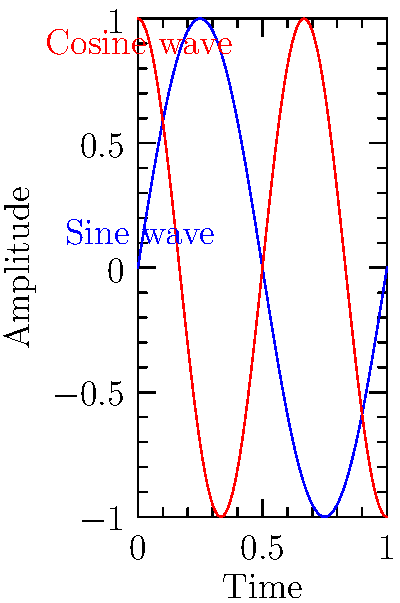In analyzing the rhythmic patterns of an eco-poem, you've mapped two recurring motifs to trigonometric functions. The blue curve represents the frequency of nature imagery (modeled by $\sin(2\pi x)$), while the red curve represents the intensity of environmental themes (modeled by $\cos(3\pi x)$). At what point in the poem (expressed as a fraction of its total length) do these two motifs align with maximum positive amplitude, symbolizing a powerful moment of eco-poetic synergy? To find when both functions reach their maximum positive amplitude simultaneously:

1) The sine function reaches its maximum of 1 when $2\pi x = \frac{\pi}{2} + 2\pi n$, where n is an integer.
   Solving for x: $x = \frac{1}{4} + n$

2) The cosine function reaches its maximum of 1 when $3\pi x = 2\pi n$, where n is an integer.
   Solving for x: $x = \frac{2n}{3}$

3) We need to find the smallest positive x that satisfies both conditions:
   $x = \frac{1}{4} + n = \frac{2m}{3}$, where n and m are integers.

4) The smallest solution is when $x = \frac{1}{4} = \frac{2}{3} - \frac{5}{12}$

5) Therefore, the functions align at their maximum when $x = \frac{1}{4}$ or $\frac{1}{4}$ of the way through the poem.

This point represents where nature imagery and environmental themes converge at their peak intensities, creating a moment of maximum eco-poetic impact.
Answer: $\frac{1}{4}$ of the poem's length 